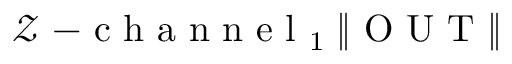Convert formula to latex. <formula><loc_0><loc_0><loc_500><loc_500>\mathcal { Z } - c h a n n e l _ { 1 } \, \| O U T \|</formula> 